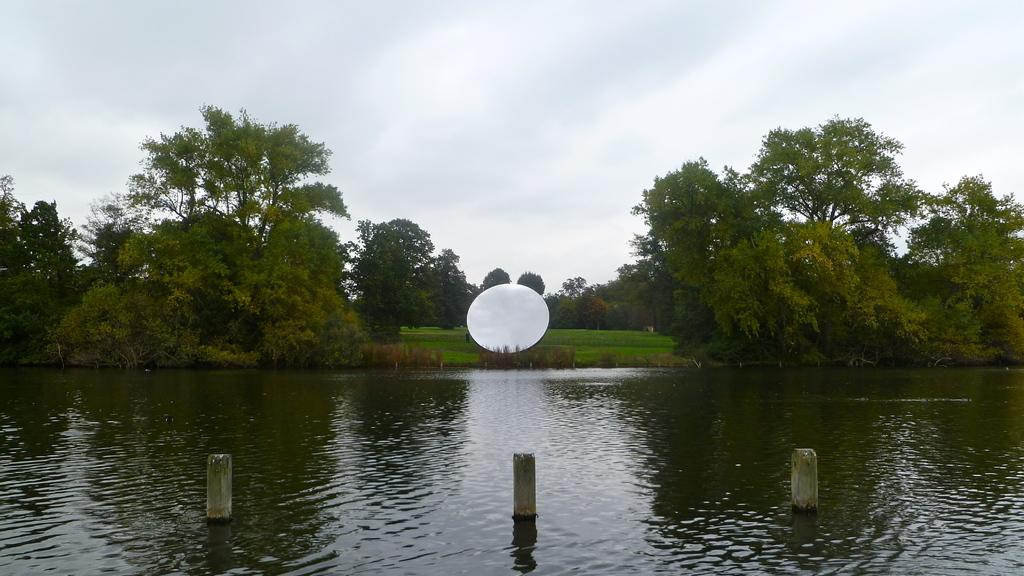What is present at the bottom of the image? There is water at the bottom side of the image. What can be seen in the water? There are bamboos in the water. What type of vegetation is visible in the background of the image? There are trees in the background of the image. What else can be seen in the background of the image? There is grassland and a water ball in the background of the image. What type of credit card is being used to purchase the bamboos in the image? There is no credit card or purchase activity depicted in the image; it shows water, bamboos, and background elements. 